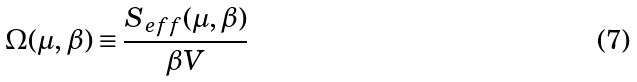Convert formula to latex. <formula><loc_0><loc_0><loc_500><loc_500>\Omega ( \mu , \beta ) \equiv \frac { S _ { e f f } ( \mu , \beta ) } { \beta V }</formula> 